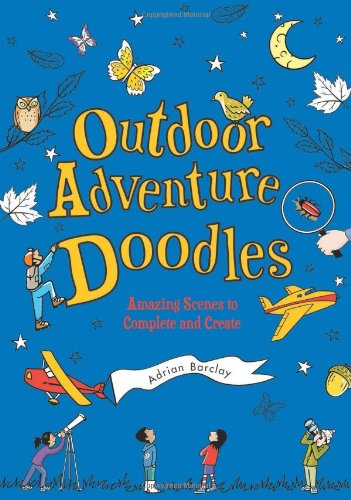Who wrote this book? The book 'Outdoor Adventure Doodles: Amazing Scenes to Complete and Create' is authored by Adrian Barclay, a creative writer known for engaging children's content. 